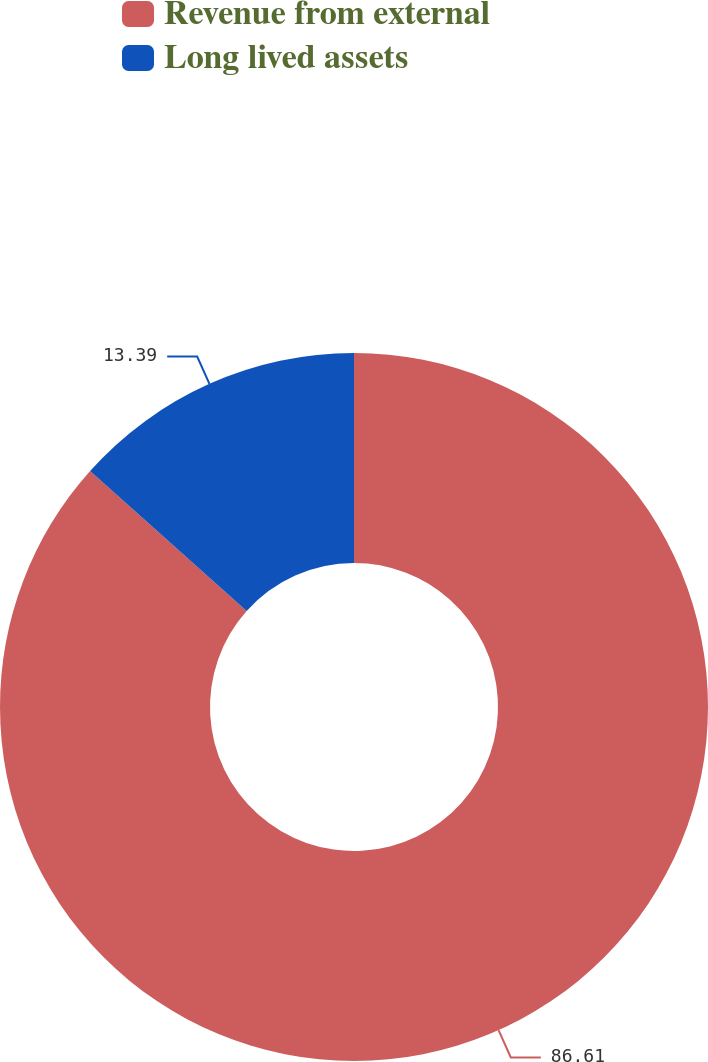Convert chart to OTSL. <chart><loc_0><loc_0><loc_500><loc_500><pie_chart><fcel>Revenue from external<fcel>Long lived assets<nl><fcel>86.61%<fcel>13.39%<nl></chart> 